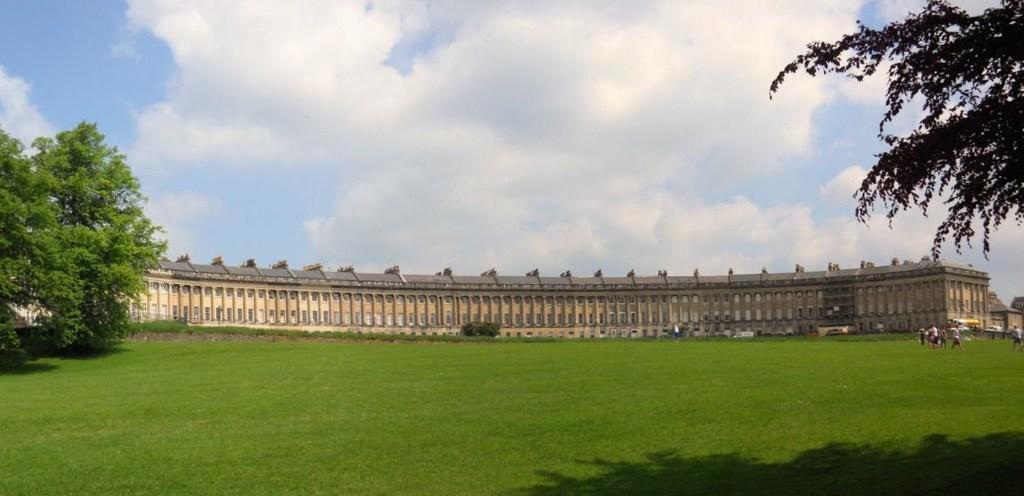Can you describe this image briefly? In this picture, we see a Royal Crescent containing many houses. At the bottom of the picture, we see grass. On either side of the picture, there are trees. On the right side, we see people standing. At the top of the picture, we see the sky and the clouds. 